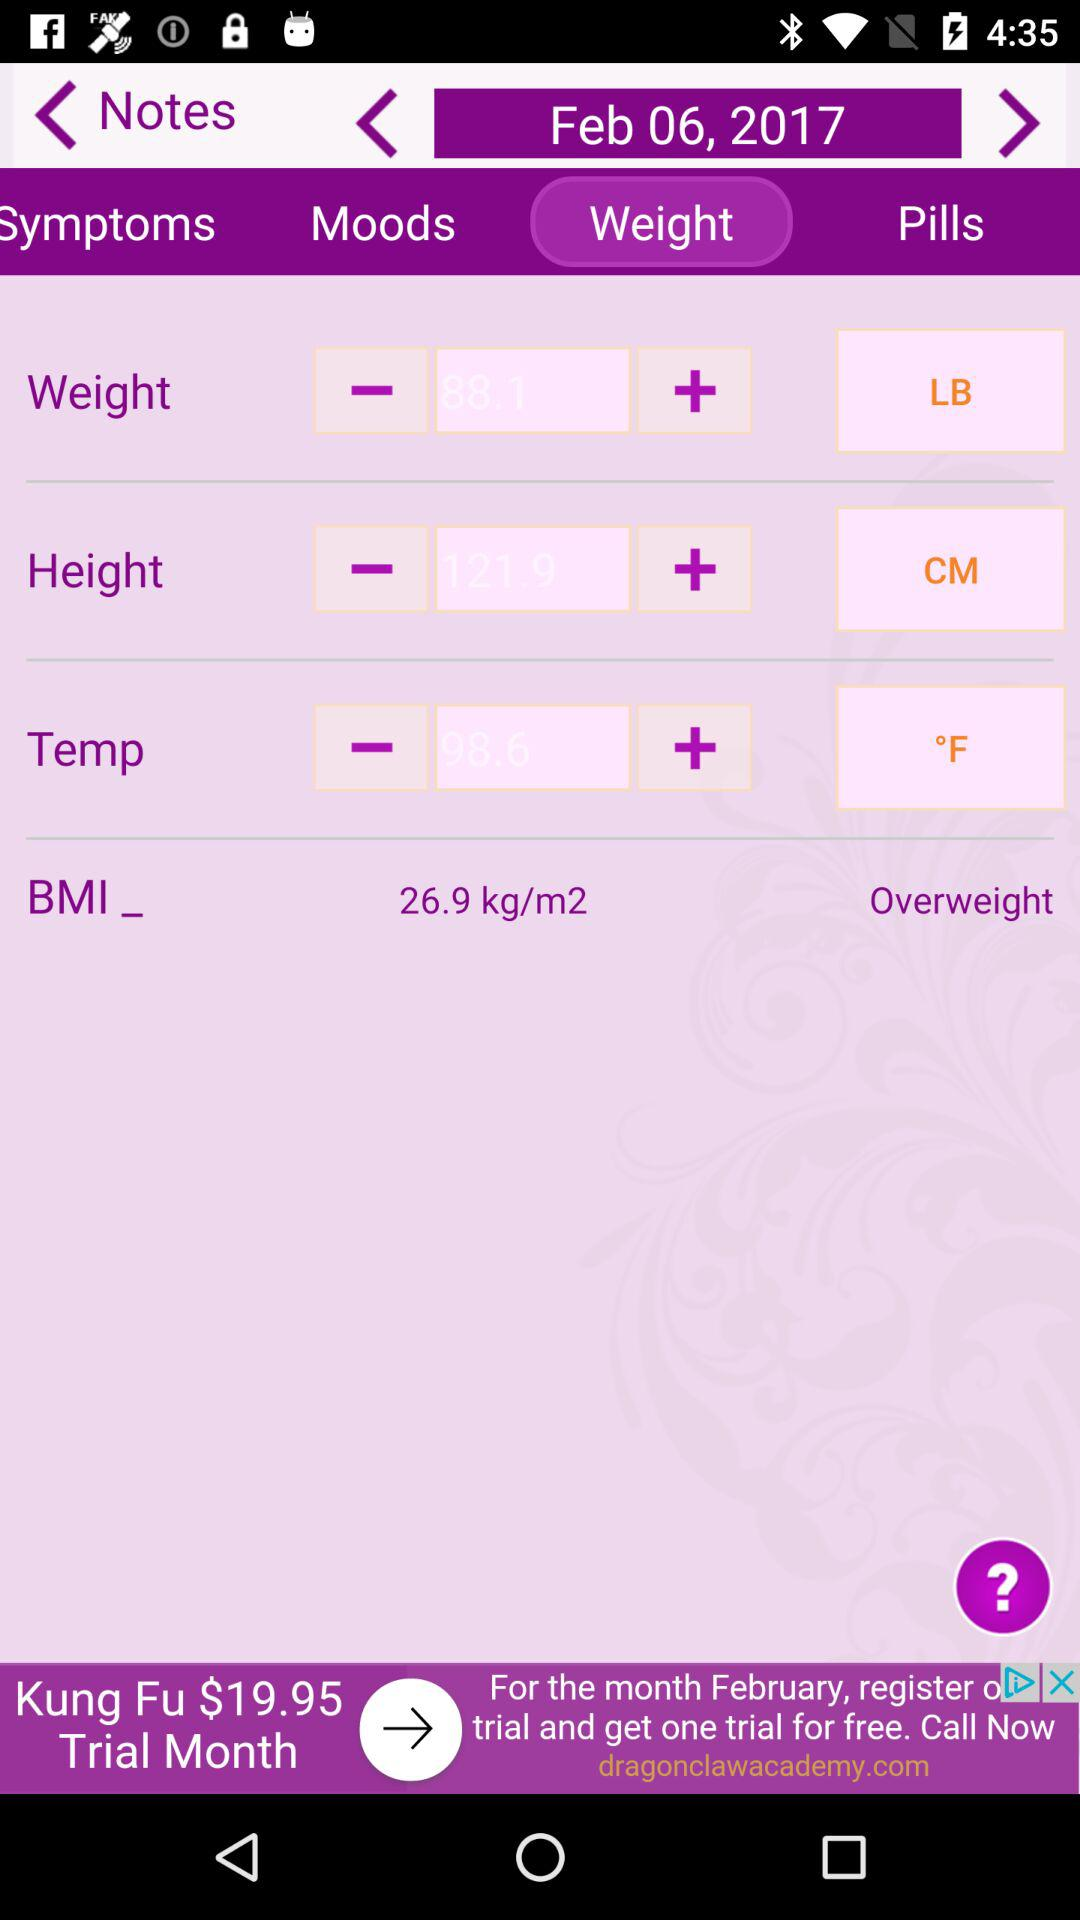What is the mentioned date? The mentioned date is February 6, 2017. 